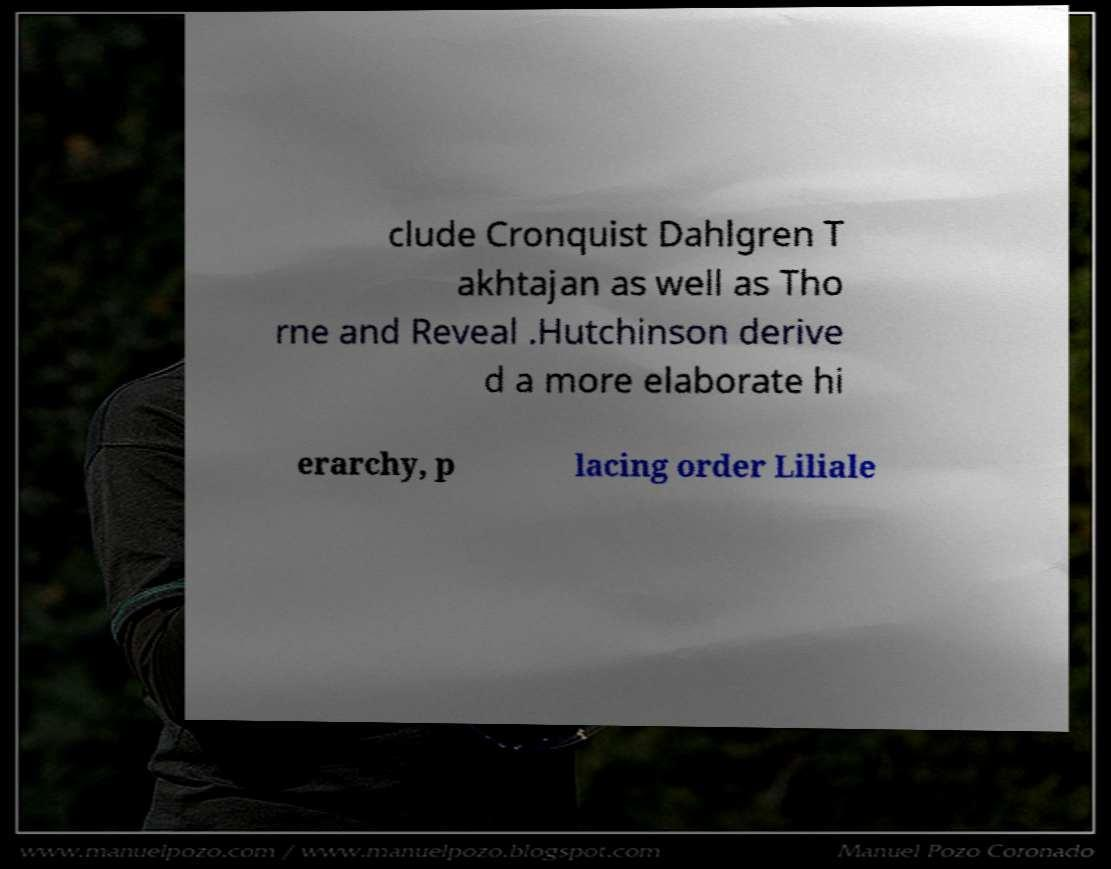Could you extract and type out the text from this image? clude Cronquist Dahlgren T akhtajan as well as Tho rne and Reveal .Hutchinson derive d a more elaborate hi erarchy, p lacing order Liliale 